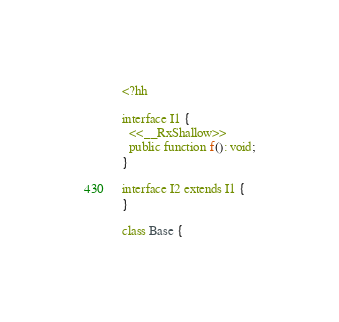Convert code to text. <code><loc_0><loc_0><loc_500><loc_500><_PHP_><?hh

interface I1 {
  <<__RxShallow>>
  public function f(): void;
}

interface I2 extends I1 {
}

class Base {</code> 